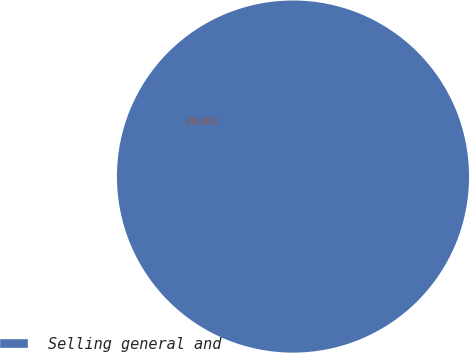<chart> <loc_0><loc_0><loc_500><loc_500><pie_chart><fcel>Selling general and<nl><fcel>100.0%<nl></chart> 